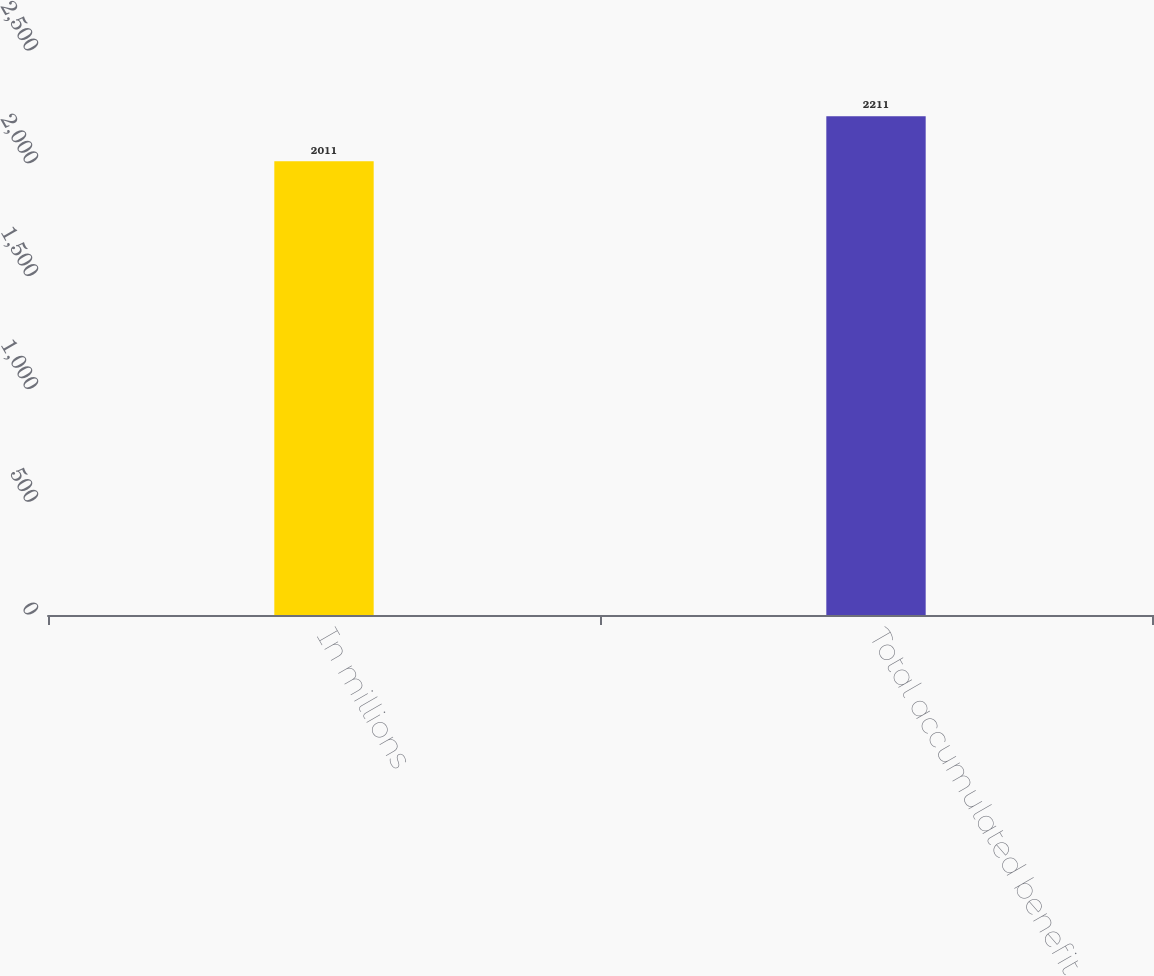<chart> <loc_0><loc_0><loc_500><loc_500><bar_chart><fcel>In millions<fcel>Total accumulated benefit<nl><fcel>2011<fcel>2211<nl></chart> 